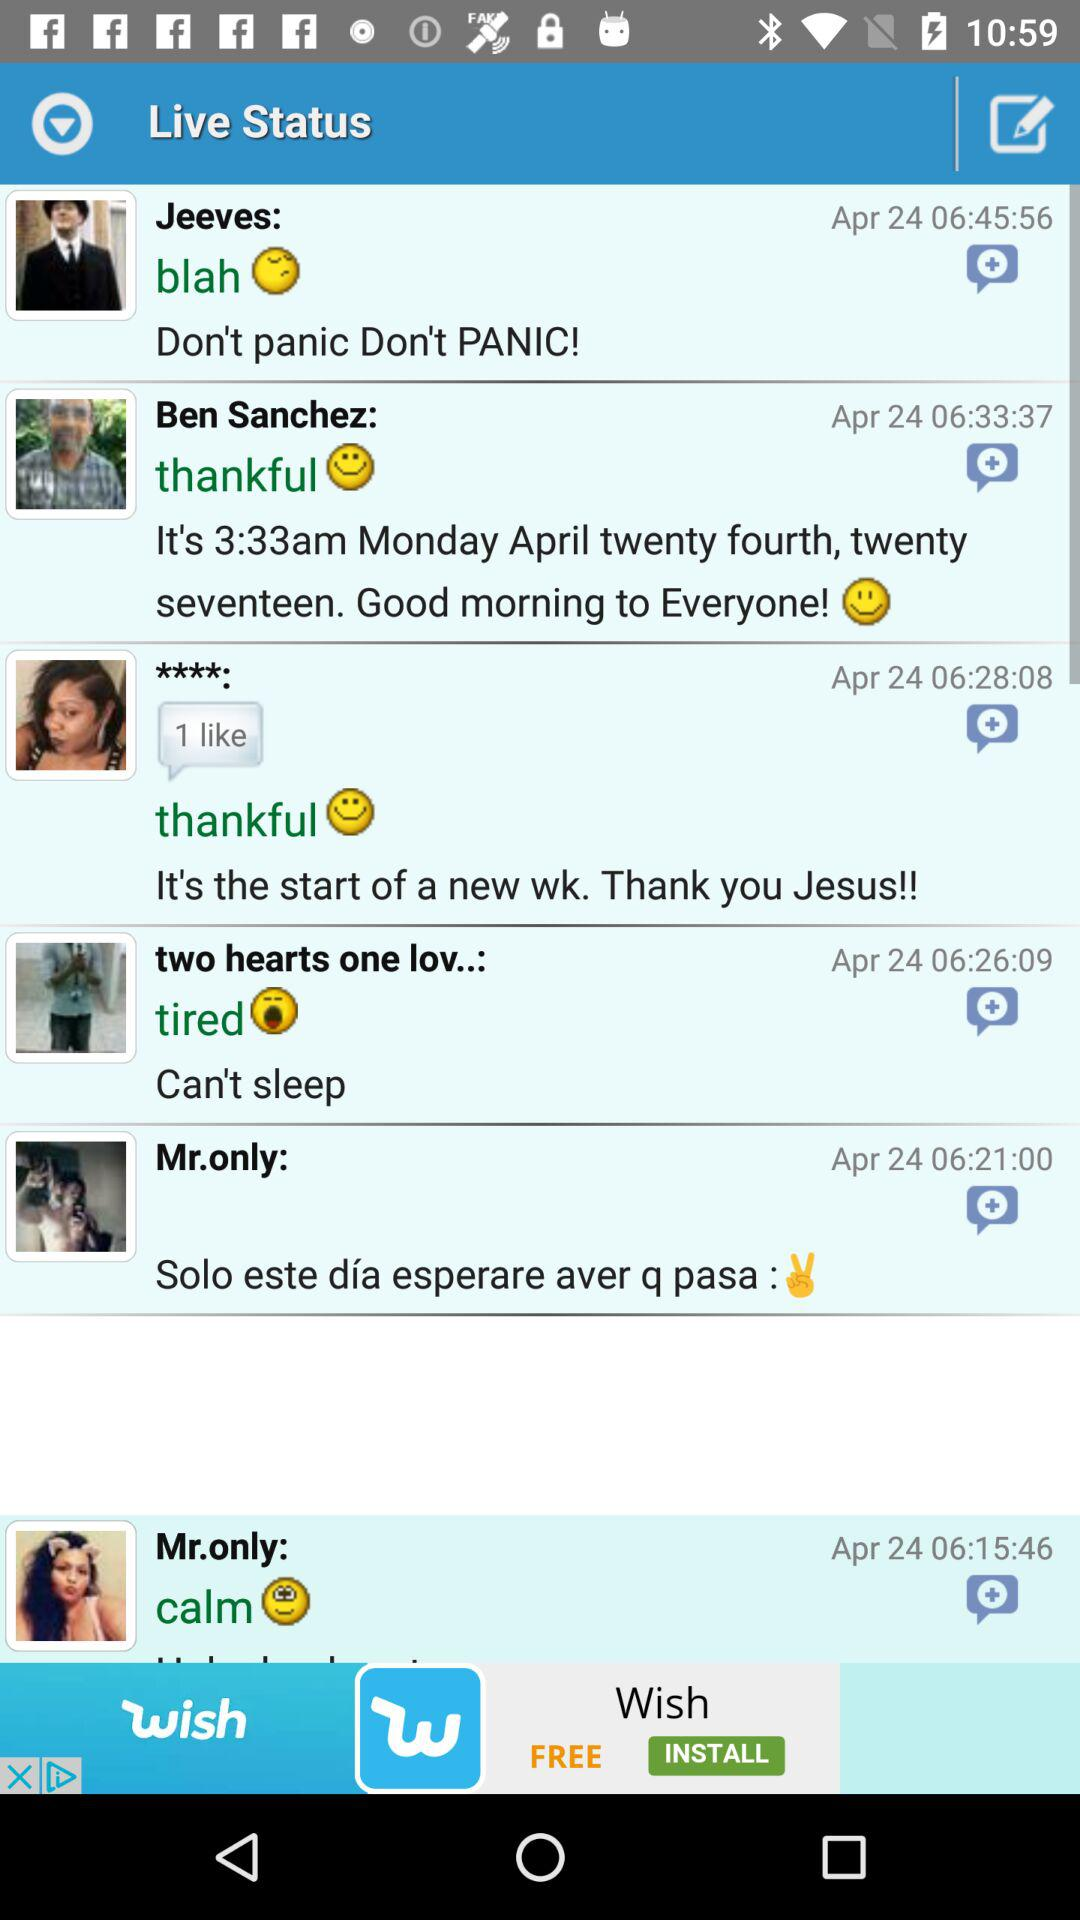What is the number of likes? The number of likes is 1. 